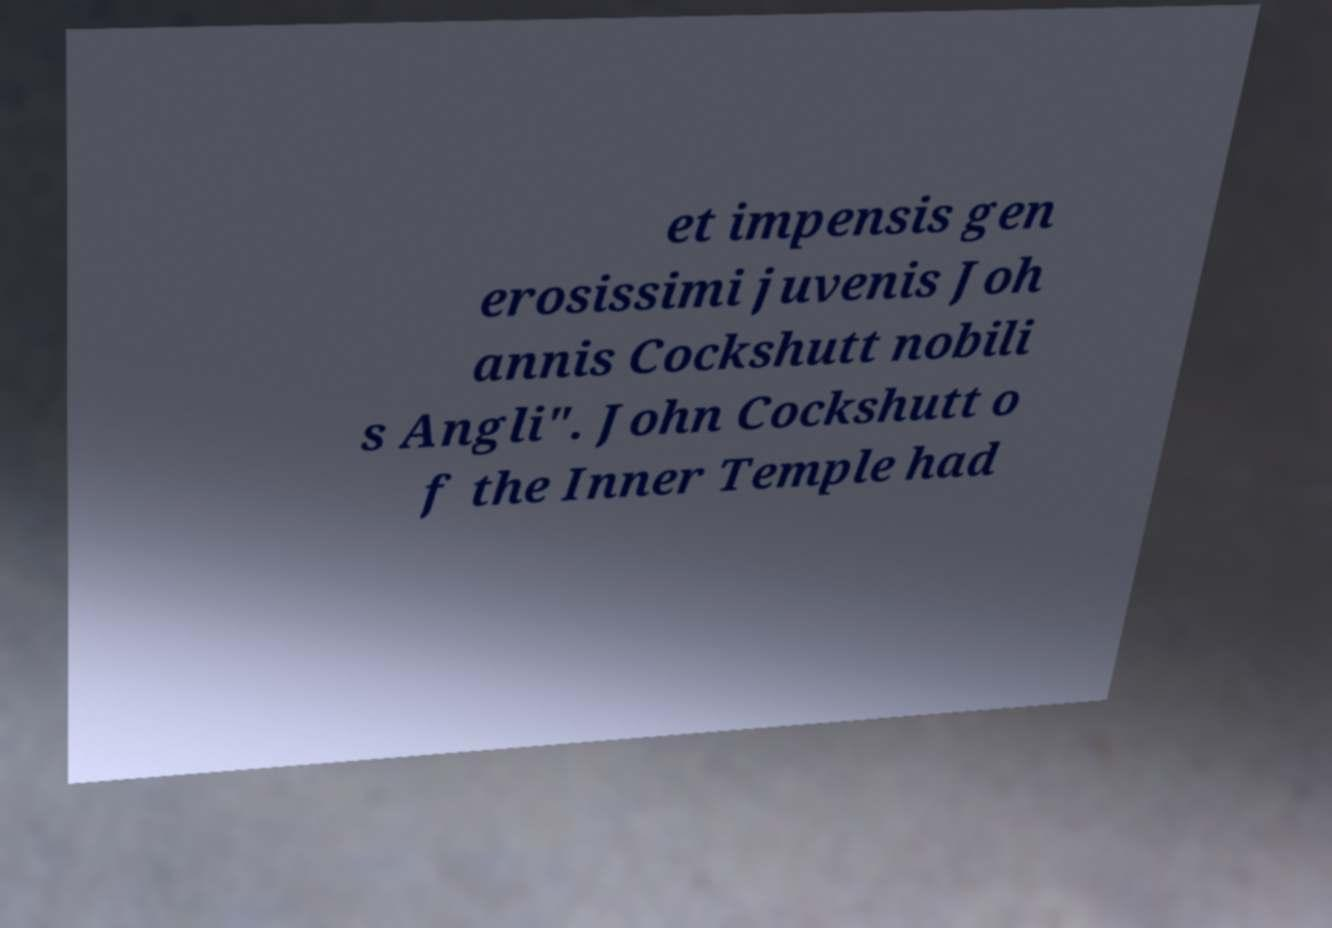Could you assist in decoding the text presented in this image and type it out clearly? et impensis gen erosissimi juvenis Joh annis Cockshutt nobili s Angli". John Cockshutt o f the Inner Temple had 